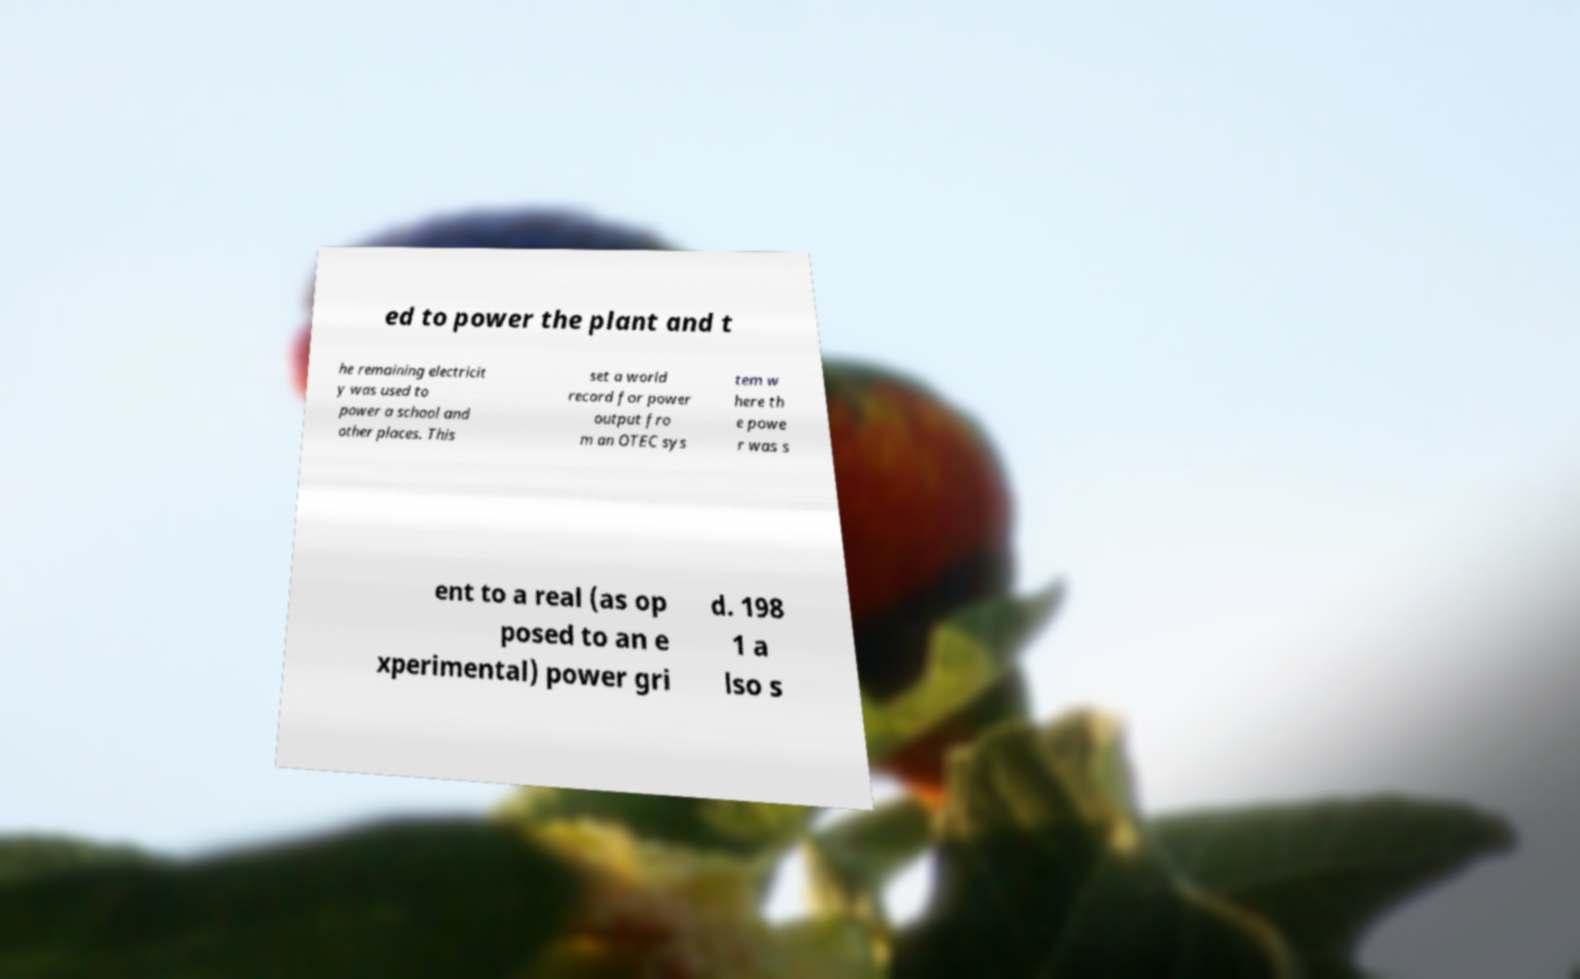What messages or text are displayed in this image? I need them in a readable, typed format. ed to power the plant and t he remaining electricit y was used to power a school and other places. This set a world record for power output fro m an OTEC sys tem w here th e powe r was s ent to a real (as op posed to an e xperimental) power gri d. 198 1 a lso s 